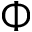<formula> <loc_0><loc_0><loc_500><loc_500>\Phi</formula> 